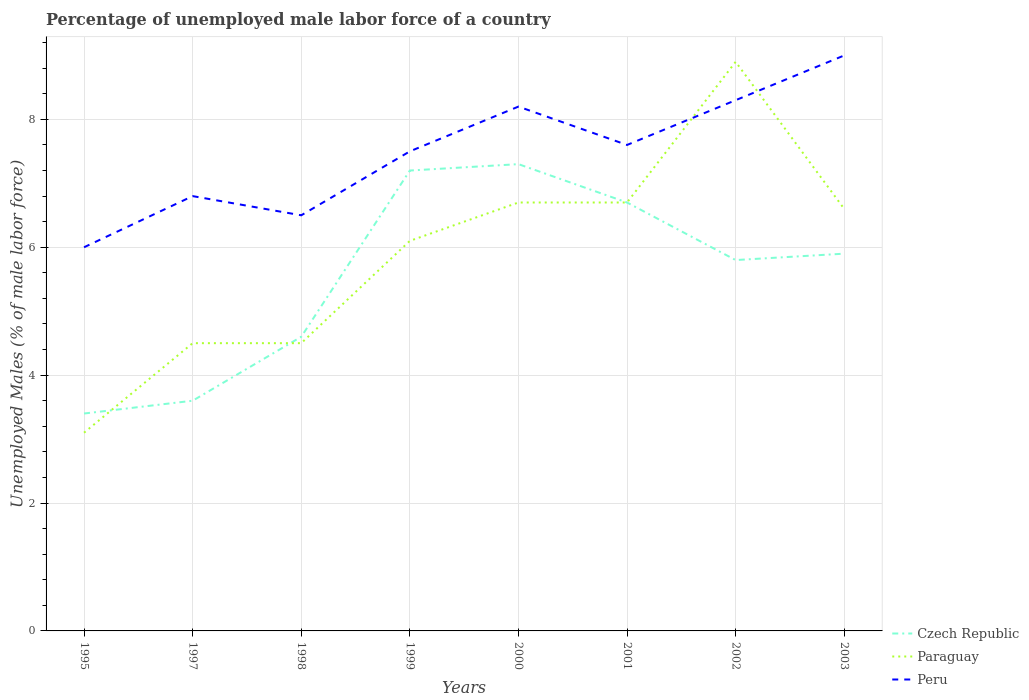How many different coloured lines are there?
Ensure brevity in your answer.  3. Does the line corresponding to Peru intersect with the line corresponding to Czech Republic?
Provide a short and direct response. No. Across all years, what is the maximum percentage of unemployed male labor force in Paraguay?
Your answer should be compact. 3.1. What is the total percentage of unemployed male labor force in Czech Republic in the graph?
Your answer should be very brief. -2.1. What is the difference between the highest and the second highest percentage of unemployed male labor force in Czech Republic?
Keep it short and to the point. 3.9. What is the difference between the highest and the lowest percentage of unemployed male labor force in Paraguay?
Your response must be concise. 5. Is the percentage of unemployed male labor force in Czech Republic strictly greater than the percentage of unemployed male labor force in Paraguay over the years?
Provide a short and direct response. No. How many lines are there?
Make the answer very short. 3. What is the difference between two consecutive major ticks on the Y-axis?
Provide a short and direct response. 2. Does the graph contain grids?
Your response must be concise. Yes. Where does the legend appear in the graph?
Your answer should be very brief. Bottom right. How many legend labels are there?
Your answer should be compact. 3. How are the legend labels stacked?
Provide a succinct answer. Vertical. What is the title of the graph?
Give a very brief answer. Percentage of unemployed male labor force of a country. What is the label or title of the Y-axis?
Your answer should be compact. Unemployed Males (% of male labor force). What is the Unemployed Males (% of male labor force) in Czech Republic in 1995?
Provide a short and direct response. 3.4. What is the Unemployed Males (% of male labor force) in Paraguay in 1995?
Offer a very short reply. 3.1. What is the Unemployed Males (% of male labor force) in Peru in 1995?
Provide a succinct answer. 6. What is the Unemployed Males (% of male labor force) of Czech Republic in 1997?
Ensure brevity in your answer.  3.6. What is the Unemployed Males (% of male labor force) in Paraguay in 1997?
Provide a short and direct response. 4.5. What is the Unemployed Males (% of male labor force) in Peru in 1997?
Offer a very short reply. 6.8. What is the Unemployed Males (% of male labor force) of Czech Republic in 1998?
Ensure brevity in your answer.  4.6. What is the Unemployed Males (% of male labor force) of Peru in 1998?
Provide a short and direct response. 6.5. What is the Unemployed Males (% of male labor force) in Czech Republic in 1999?
Offer a terse response. 7.2. What is the Unemployed Males (% of male labor force) of Paraguay in 1999?
Keep it short and to the point. 6.1. What is the Unemployed Males (% of male labor force) of Peru in 1999?
Make the answer very short. 7.5. What is the Unemployed Males (% of male labor force) in Czech Republic in 2000?
Offer a very short reply. 7.3. What is the Unemployed Males (% of male labor force) of Paraguay in 2000?
Keep it short and to the point. 6.7. What is the Unemployed Males (% of male labor force) of Peru in 2000?
Offer a terse response. 8.2. What is the Unemployed Males (% of male labor force) of Czech Republic in 2001?
Your answer should be compact. 6.7. What is the Unemployed Males (% of male labor force) of Paraguay in 2001?
Offer a very short reply. 6.7. What is the Unemployed Males (% of male labor force) in Peru in 2001?
Offer a very short reply. 7.6. What is the Unemployed Males (% of male labor force) in Czech Republic in 2002?
Your answer should be compact. 5.8. What is the Unemployed Males (% of male labor force) in Paraguay in 2002?
Provide a succinct answer. 8.9. What is the Unemployed Males (% of male labor force) of Peru in 2002?
Give a very brief answer. 8.3. What is the Unemployed Males (% of male labor force) of Czech Republic in 2003?
Make the answer very short. 5.9. What is the Unemployed Males (% of male labor force) in Paraguay in 2003?
Give a very brief answer. 6.6. What is the Unemployed Males (% of male labor force) in Peru in 2003?
Provide a succinct answer. 9. Across all years, what is the maximum Unemployed Males (% of male labor force) in Czech Republic?
Provide a succinct answer. 7.3. Across all years, what is the maximum Unemployed Males (% of male labor force) of Paraguay?
Your answer should be compact. 8.9. Across all years, what is the maximum Unemployed Males (% of male labor force) in Peru?
Provide a short and direct response. 9. Across all years, what is the minimum Unemployed Males (% of male labor force) of Czech Republic?
Offer a terse response. 3.4. Across all years, what is the minimum Unemployed Males (% of male labor force) of Paraguay?
Your answer should be compact. 3.1. Across all years, what is the minimum Unemployed Males (% of male labor force) of Peru?
Your answer should be compact. 6. What is the total Unemployed Males (% of male labor force) of Czech Republic in the graph?
Ensure brevity in your answer.  44.5. What is the total Unemployed Males (% of male labor force) in Paraguay in the graph?
Your answer should be very brief. 47.1. What is the total Unemployed Males (% of male labor force) in Peru in the graph?
Give a very brief answer. 59.9. What is the difference between the Unemployed Males (% of male labor force) in Czech Republic in 1995 and that in 1997?
Offer a terse response. -0.2. What is the difference between the Unemployed Males (% of male labor force) in Peru in 1995 and that in 1997?
Your answer should be very brief. -0.8. What is the difference between the Unemployed Males (% of male labor force) of Paraguay in 1995 and that in 1998?
Offer a very short reply. -1.4. What is the difference between the Unemployed Males (% of male labor force) of Paraguay in 1995 and that in 1999?
Provide a short and direct response. -3. What is the difference between the Unemployed Males (% of male labor force) of Peru in 1995 and that in 1999?
Offer a very short reply. -1.5. What is the difference between the Unemployed Males (% of male labor force) of Paraguay in 1995 and that in 2000?
Your answer should be very brief. -3.6. What is the difference between the Unemployed Males (% of male labor force) in Peru in 1995 and that in 2000?
Offer a very short reply. -2.2. What is the difference between the Unemployed Males (% of male labor force) of Czech Republic in 1995 and that in 2002?
Your answer should be compact. -2.4. What is the difference between the Unemployed Males (% of male labor force) in Paraguay in 1995 and that in 2002?
Your response must be concise. -5.8. What is the difference between the Unemployed Males (% of male labor force) in Paraguay in 1995 and that in 2003?
Provide a short and direct response. -3.5. What is the difference between the Unemployed Males (% of male labor force) of Czech Republic in 1997 and that in 1998?
Ensure brevity in your answer.  -1. What is the difference between the Unemployed Males (% of male labor force) of Paraguay in 1997 and that in 1998?
Your answer should be compact. 0. What is the difference between the Unemployed Males (% of male labor force) in Peru in 1997 and that in 1998?
Make the answer very short. 0.3. What is the difference between the Unemployed Males (% of male labor force) in Czech Republic in 1997 and that in 1999?
Provide a succinct answer. -3.6. What is the difference between the Unemployed Males (% of male labor force) in Paraguay in 1997 and that in 1999?
Ensure brevity in your answer.  -1.6. What is the difference between the Unemployed Males (% of male labor force) in Peru in 1997 and that in 1999?
Your response must be concise. -0.7. What is the difference between the Unemployed Males (% of male labor force) of Czech Republic in 1997 and that in 2000?
Offer a terse response. -3.7. What is the difference between the Unemployed Males (% of male labor force) of Peru in 1997 and that in 2001?
Offer a terse response. -0.8. What is the difference between the Unemployed Males (% of male labor force) of Peru in 1998 and that in 2000?
Offer a terse response. -1.7. What is the difference between the Unemployed Males (% of male labor force) of Paraguay in 1998 and that in 2001?
Provide a succinct answer. -2.2. What is the difference between the Unemployed Males (% of male labor force) of Czech Republic in 1998 and that in 2002?
Give a very brief answer. -1.2. What is the difference between the Unemployed Males (% of male labor force) in Paraguay in 1998 and that in 2002?
Make the answer very short. -4.4. What is the difference between the Unemployed Males (% of male labor force) of Czech Republic in 1998 and that in 2003?
Provide a succinct answer. -1.3. What is the difference between the Unemployed Males (% of male labor force) of Czech Republic in 1999 and that in 2000?
Your response must be concise. -0.1. What is the difference between the Unemployed Males (% of male labor force) of Peru in 1999 and that in 2000?
Offer a terse response. -0.7. What is the difference between the Unemployed Males (% of male labor force) in Paraguay in 1999 and that in 2001?
Make the answer very short. -0.6. What is the difference between the Unemployed Males (% of male labor force) of Peru in 1999 and that in 2001?
Provide a short and direct response. -0.1. What is the difference between the Unemployed Males (% of male labor force) in Czech Republic in 1999 and that in 2002?
Offer a very short reply. 1.4. What is the difference between the Unemployed Males (% of male labor force) in Czech Republic in 1999 and that in 2003?
Your answer should be compact. 1.3. What is the difference between the Unemployed Males (% of male labor force) in Peru in 1999 and that in 2003?
Provide a succinct answer. -1.5. What is the difference between the Unemployed Males (% of male labor force) of Paraguay in 2000 and that in 2001?
Keep it short and to the point. 0. What is the difference between the Unemployed Males (% of male labor force) of Czech Republic in 2000 and that in 2002?
Ensure brevity in your answer.  1.5. What is the difference between the Unemployed Males (% of male labor force) of Paraguay in 2000 and that in 2002?
Provide a short and direct response. -2.2. What is the difference between the Unemployed Males (% of male labor force) in Czech Republic in 2000 and that in 2003?
Offer a very short reply. 1.4. What is the difference between the Unemployed Males (% of male labor force) of Paraguay in 2000 and that in 2003?
Provide a succinct answer. 0.1. What is the difference between the Unemployed Males (% of male labor force) in Peru in 2000 and that in 2003?
Your response must be concise. -0.8. What is the difference between the Unemployed Males (% of male labor force) in Paraguay in 2001 and that in 2002?
Ensure brevity in your answer.  -2.2. What is the difference between the Unemployed Males (% of male labor force) of Peru in 2001 and that in 2002?
Your response must be concise. -0.7. What is the difference between the Unemployed Males (% of male labor force) of Peru in 2001 and that in 2003?
Your response must be concise. -1.4. What is the difference between the Unemployed Males (% of male labor force) of Czech Republic in 2002 and that in 2003?
Your response must be concise. -0.1. What is the difference between the Unemployed Males (% of male labor force) of Peru in 2002 and that in 2003?
Your response must be concise. -0.7. What is the difference between the Unemployed Males (% of male labor force) of Czech Republic in 1995 and the Unemployed Males (% of male labor force) of Paraguay in 1998?
Provide a short and direct response. -1.1. What is the difference between the Unemployed Males (% of male labor force) of Paraguay in 1995 and the Unemployed Males (% of male labor force) of Peru in 1998?
Offer a very short reply. -3.4. What is the difference between the Unemployed Males (% of male labor force) of Paraguay in 1995 and the Unemployed Males (% of male labor force) of Peru in 1999?
Your response must be concise. -4.4. What is the difference between the Unemployed Males (% of male labor force) of Czech Republic in 1995 and the Unemployed Males (% of male labor force) of Paraguay in 2000?
Keep it short and to the point. -3.3. What is the difference between the Unemployed Males (% of male labor force) of Czech Republic in 1995 and the Unemployed Males (% of male labor force) of Peru in 2000?
Your answer should be compact. -4.8. What is the difference between the Unemployed Males (% of male labor force) of Paraguay in 1995 and the Unemployed Males (% of male labor force) of Peru in 2000?
Provide a succinct answer. -5.1. What is the difference between the Unemployed Males (% of male labor force) of Czech Republic in 1995 and the Unemployed Males (% of male labor force) of Peru in 2001?
Offer a very short reply. -4.2. What is the difference between the Unemployed Males (% of male labor force) of Czech Republic in 1995 and the Unemployed Males (% of male labor force) of Paraguay in 2002?
Ensure brevity in your answer.  -5.5. What is the difference between the Unemployed Males (% of male labor force) in Paraguay in 1995 and the Unemployed Males (% of male labor force) in Peru in 2002?
Provide a succinct answer. -5.2. What is the difference between the Unemployed Males (% of male labor force) in Czech Republic in 1997 and the Unemployed Males (% of male labor force) in Paraguay in 1998?
Give a very brief answer. -0.9. What is the difference between the Unemployed Males (% of male labor force) of Czech Republic in 1997 and the Unemployed Males (% of male labor force) of Peru in 1998?
Make the answer very short. -2.9. What is the difference between the Unemployed Males (% of male labor force) in Paraguay in 1997 and the Unemployed Males (% of male labor force) in Peru in 1998?
Your response must be concise. -2. What is the difference between the Unemployed Males (% of male labor force) in Czech Republic in 1997 and the Unemployed Males (% of male labor force) in Peru in 1999?
Your answer should be very brief. -3.9. What is the difference between the Unemployed Males (% of male labor force) in Paraguay in 1997 and the Unemployed Males (% of male labor force) in Peru in 1999?
Provide a short and direct response. -3. What is the difference between the Unemployed Males (% of male labor force) of Czech Republic in 1997 and the Unemployed Males (% of male labor force) of Peru in 2000?
Provide a short and direct response. -4.6. What is the difference between the Unemployed Males (% of male labor force) in Paraguay in 1997 and the Unemployed Males (% of male labor force) in Peru in 2000?
Your answer should be compact. -3.7. What is the difference between the Unemployed Males (% of male labor force) of Czech Republic in 1997 and the Unemployed Males (% of male labor force) of Paraguay in 2001?
Ensure brevity in your answer.  -3.1. What is the difference between the Unemployed Males (% of male labor force) in Paraguay in 1997 and the Unemployed Males (% of male labor force) in Peru in 2001?
Make the answer very short. -3.1. What is the difference between the Unemployed Males (% of male labor force) of Paraguay in 1997 and the Unemployed Males (% of male labor force) of Peru in 2002?
Offer a terse response. -3.8. What is the difference between the Unemployed Males (% of male labor force) in Czech Republic in 1997 and the Unemployed Males (% of male labor force) in Paraguay in 2003?
Your answer should be very brief. -3. What is the difference between the Unemployed Males (% of male labor force) in Czech Republic in 1997 and the Unemployed Males (% of male labor force) in Peru in 2003?
Provide a short and direct response. -5.4. What is the difference between the Unemployed Males (% of male labor force) in Czech Republic in 1998 and the Unemployed Males (% of male labor force) in Paraguay in 1999?
Give a very brief answer. -1.5. What is the difference between the Unemployed Males (% of male labor force) of Czech Republic in 1998 and the Unemployed Males (% of male labor force) of Peru in 2000?
Your answer should be compact. -3.6. What is the difference between the Unemployed Males (% of male labor force) in Paraguay in 1998 and the Unemployed Males (% of male labor force) in Peru in 2000?
Your answer should be compact. -3.7. What is the difference between the Unemployed Males (% of male labor force) of Czech Republic in 1998 and the Unemployed Males (% of male labor force) of Paraguay in 2001?
Your answer should be compact. -2.1. What is the difference between the Unemployed Males (% of male labor force) of Czech Republic in 1998 and the Unemployed Males (% of male labor force) of Peru in 2001?
Your answer should be very brief. -3. What is the difference between the Unemployed Males (% of male labor force) of Paraguay in 1998 and the Unemployed Males (% of male labor force) of Peru in 2001?
Provide a short and direct response. -3.1. What is the difference between the Unemployed Males (% of male labor force) in Czech Republic in 1998 and the Unemployed Males (% of male labor force) in Peru in 2002?
Make the answer very short. -3.7. What is the difference between the Unemployed Males (% of male labor force) of Czech Republic in 1999 and the Unemployed Males (% of male labor force) of Paraguay in 2000?
Provide a short and direct response. 0.5. What is the difference between the Unemployed Males (% of male labor force) of Paraguay in 1999 and the Unemployed Males (% of male labor force) of Peru in 2000?
Provide a short and direct response. -2.1. What is the difference between the Unemployed Males (% of male labor force) of Czech Republic in 1999 and the Unemployed Males (% of male labor force) of Paraguay in 2001?
Offer a very short reply. 0.5. What is the difference between the Unemployed Males (% of male labor force) in Czech Republic in 1999 and the Unemployed Males (% of male labor force) in Peru in 2001?
Provide a succinct answer. -0.4. What is the difference between the Unemployed Males (% of male labor force) in Czech Republic in 1999 and the Unemployed Males (% of male labor force) in Paraguay in 2002?
Ensure brevity in your answer.  -1.7. What is the difference between the Unemployed Males (% of male labor force) of Czech Republic in 1999 and the Unemployed Males (% of male labor force) of Peru in 2002?
Your answer should be compact. -1.1. What is the difference between the Unemployed Males (% of male labor force) of Paraguay in 1999 and the Unemployed Males (% of male labor force) of Peru in 2002?
Provide a succinct answer. -2.2. What is the difference between the Unemployed Males (% of male labor force) in Czech Republic in 1999 and the Unemployed Males (% of male labor force) in Paraguay in 2003?
Make the answer very short. 0.6. What is the difference between the Unemployed Males (% of male labor force) in Czech Republic in 2000 and the Unemployed Males (% of male labor force) in Paraguay in 2002?
Keep it short and to the point. -1.6. What is the difference between the Unemployed Males (% of male labor force) of Czech Republic in 2000 and the Unemployed Males (% of male labor force) of Peru in 2002?
Your response must be concise. -1. What is the difference between the Unemployed Males (% of male labor force) of Czech Republic in 2000 and the Unemployed Males (% of male labor force) of Peru in 2003?
Provide a succinct answer. -1.7. What is the difference between the Unemployed Males (% of male labor force) of Paraguay in 2000 and the Unemployed Males (% of male labor force) of Peru in 2003?
Provide a short and direct response. -2.3. What is the difference between the Unemployed Males (% of male labor force) of Paraguay in 2001 and the Unemployed Males (% of male labor force) of Peru in 2003?
Your answer should be compact. -2.3. What is the difference between the Unemployed Males (% of male labor force) of Czech Republic in 2002 and the Unemployed Males (% of male labor force) of Peru in 2003?
Your answer should be very brief. -3.2. What is the difference between the Unemployed Males (% of male labor force) in Paraguay in 2002 and the Unemployed Males (% of male labor force) in Peru in 2003?
Make the answer very short. -0.1. What is the average Unemployed Males (% of male labor force) of Czech Republic per year?
Keep it short and to the point. 5.56. What is the average Unemployed Males (% of male labor force) in Paraguay per year?
Make the answer very short. 5.89. What is the average Unemployed Males (% of male labor force) in Peru per year?
Provide a short and direct response. 7.49. In the year 1995, what is the difference between the Unemployed Males (% of male labor force) in Czech Republic and Unemployed Males (% of male labor force) in Paraguay?
Provide a short and direct response. 0.3. In the year 1997, what is the difference between the Unemployed Males (% of male labor force) in Czech Republic and Unemployed Males (% of male labor force) in Paraguay?
Offer a very short reply. -0.9. In the year 1998, what is the difference between the Unemployed Males (% of male labor force) of Czech Republic and Unemployed Males (% of male labor force) of Peru?
Offer a terse response. -1.9. In the year 1999, what is the difference between the Unemployed Males (% of male labor force) in Czech Republic and Unemployed Males (% of male labor force) in Peru?
Provide a short and direct response. -0.3. In the year 2000, what is the difference between the Unemployed Males (% of male labor force) in Czech Republic and Unemployed Males (% of male labor force) in Paraguay?
Provide a short and direct response. 0.6. In the year 2001, what is the difference between the Unemployed Males (% of male labor force) in Czech Republic and Unemployed Males (% of male labor force) in Peru?
Ensure brevity in your answer.  -0.9. In the year 2001, what is the difference between the Unemployed Males (% of male labor force) in Paraguay and Unemployed Males (% of male labor force) in Peru?
Offer a very short reply. -0.9. In the year 2002, what is the difference between the Unemployed Males (% of male labor force) in Czech Republic and Unemployed Males (% of male labor force) in Paraguay?
Ensure brevity in your answer.  -3.1. In the year 2002, what is the difference between the Unemployed Males (% of male labor force) of Czech Republic and Unemployed Males (% of male labor force) of Peru?
Your answer should be very brief. -2.5. In the year 2003, what is the difference between the Unemployed Males (% of male labor force) of Czech Republic and Unemployed Males (% of male labor force) of Peru?
Ensure brevity in your answer.  -3.1. What is the ratio of the Unemployed Males (% of male labor force) in Czech Republic in 1995 to that in 1997?
Keep it short and to the point. 0.94. What is the ratio of the Unemployed Males (% of male labor force) in Paraguay in 1995 to that in 1997?
Ensure brevity in your answer.  0.69. What is the ratio of the Unemployed Males (% of male labor force) of Peru in 1995 to that in 1997?
Provide a succinct answer. 0.88. What is the ratio of the Unemployed Males (% of male labor force) in Czech Republic in 1995 to that in 1998?
Your response must be concise. 0.74. What is the ratio of the Unemployed Males (% of male labor force) of Paraguay in 1995 to that in 1998?
Provide a succinct answer. 0.69. What is the ratio of the Unemployed Males (% of male labor force) in Czech Republic in 1995 to that in 1999?
Your answer should be very brief. 0.47. What is the ratio of the Unemployed Males (% of male labor force) in Paraguay in 1995 to that in 1999?
Provide a short and direct response. 0.51. What is the ratio of the Unemployed Males (% of male labor force) in Peru in 1995 to that in 1999?
Offer a terse response. 0.8. What is the ratio of the Unemployed Males (% of male labor force) in Czech Republic in 1995 to that in 2000?
Ensure brevity in your answer.  0.47. What is the ratio of the Unemployed Males (% of male labor force) of Paraguay in 1995 to that in 2000?
Your answer should be compact. 0.46. What is the ratio of the Unemployed Males (% of male labor force) in Peru in 1995 to that in 2000?
Provide a succinct answer. 0.73. What is the ratio of the Unemployed Males (% of male labor force) of Czech Republic in 1995 to that in 2001?
Your answer should be compact. 0.51. What is the ratio of the Unemployed Males (% of male labor force) of Paraguay in 1995 to that in 2001?
Provide a short and direct response. 0.46. What is the ratio of the Unemployed Males (% of male labor force) of Peru in 1995 to that in 2001?
Provide a short and direct response. 0.79. What is the ratio of the Unemployed Males (% of male labor force) of Czech Republic in 1995 to that in 2002?
Give a very brief answer. 0.59. What is the ratio of the Unemployed Males (% of male labor force) in Paraguay in 1995 to that in 2002?
Your answer should be compact. 0.35. What is the ratio of the Unemployed Males (% of male labor force) of Peru in 1995 to that in 2002?
Your answer should be compact. 0.72. What is the ratio of the Unemployed Males (% of male labor force) in Czech Republic in 1995 to that in 2003?
Your answer should be compact. 0.58. What is the ratio of the Unemployed Males (% of male labor force) of Paraguay in 1995 to that in 2003?
Keep it short and to the point. 0.47. What is the ratio of the Unemployed Males (% of male labor force) in Czech Republic in 1997 to that in 1998?
Ensure brevity in your answer.  0.78. What is the ratio of the Unemployed Males (% of male labor force) in Peru in 1997 to that in 1998?
Provide a succinct answer. 1.05. What is the ratio of the Unemployed Males (% of male labor force) of Paraguay in 1997 to that in 1999?
Offer a terse response. 0.74. What is the ratio of the Unemployed Males (% of male labor force) of Peru in 1997 to that in 1999?
Your response must be concise. 0.91. What is the ratio of the Unemployed Males (% of male labor force) of Czech Republic in 1997 to that in 2000?
Provide a short and direct response. 0.49. What is the ratio of the Unemployed Males (% of male labor force) in Paraguay in 1997 to that in 2000?
Your response must be concise. 0.67. What is the ratio of the Unemployed Males (% of male labor force) in Peru in 1997 to that in 2000?
Offer a terse response. 0.83. What is the ratio of the Unemployed Males (% of male labor force) in Czech Republic in 1997 to that in 2001?
Provide a succinct answer. 0.54. What is the ratio of the Unemployed Males (% of male labor force) of Paraguay in 1997 to that in 2001?
Provide a short and direct response. 0.67. What is the ratio of the Unemployed Males (% of male labor force) of Peru in 1997 to that in 2001?
Provide a succinct answer. 0.89. What is the ratio of the Unemployed Males (% of male labor force) of Czech Republic in 1997 to that in 2002?
Make the answer very short. 0.62. What is the ratio of the Unemployed Males (% of male labor force) of Paraguay in 1997 to that in 2002?
Your answer should be compact. 0.51. What is the ratio of the Unemployed Males (% of male labor force) in Peru in 1997 to that in 2002?
Give a very brief answer. 0.82. What is the ratio of the Unemployed Males (% of male labor force) in Czech Republic in 1997 to that in 2003?
Offer a terse response. 0.61. What is the ratio of the Unemployed Males (% of male labor force) in Paraguay in 1997 to that in 2003?
Your response must be concise. 0.68. What is the ratio of the Unemployed Males (% of male labor force) in Peru in 1997 to that in 2003?
Offer a very short reply. 0.76. What is the ratio of the Unemployed Males (% of male labor force) in Czech Republic in 1998 to that in 1999?
Your answer should be very brief. 0.64. What is the ratio of the Unemployed Males (% of male labor force) of Paraguay in 1998 to that in 1999?
Offer a very short reply. 0.74. What is the ratio of the Unemployed Males (% of male labor force) in Peru in 1998 to that in 1999?
Your response must be concise. 0.87. What is the ratio of the Unemployed Males (% of male labor force) in Czech Republic in 1998 to that in 2000?
Your response must be concise. 0.63. What is the ratio of the Unemployed Males (% of male labor force) in Paraguay in 1998 to that in 2000?
Keep it short and to the point. 0.67. What is the ratio of the Unemployed Males (% of male labor force) of Peru in 1998 to that in 2000?
Keep it short and to the point. 0.79. What is the ratio of the Unemployed Males (% of male labor force) of Czech Republic in 1998 to that in 2001?
Provide a short and direct response. 0.69. What is the ratio of the Unemployed Males (% of male labor force) of Paraguay in 1998 to that in 2001?
Offer a very short reply. 0.67. What is the ratio of the Unemployed Males (% of male labor force) in Peru in 1998 to that in 2001?
Your answer should be very brief. 0.86. What is the ratio of the Unemployed Males (% of male labor force) in Czech Republic in 1998 to that in 2002?
Your answer should be compact. 0.79. What is the ratio of the Unemployed Males (% of male labor force) of Paraguay in 1998 to that in 2002?
Your response must be concise. 0.51. What is the ratio of the Unemployed Males (% of male labor force) of Peru in 1998 to that in 2002?
Your response must be concise. 0.78. What is the ratio of the Unemployed Males (% of male labor force) in Czech Republic in 1998 to that in 2003?
Offer a terse response. 0.78. What is the ratio of the Unemployed Males (% of male labor force) of Paraguay in 1998 to that in 2003?
Offer a terse response. 0.68. What is the ratio of the Unemployed Males (% of male labor force) in Peru in 1998 to that in 2003?
Your answer should be very brief. 0.72. What is the ratio of the Unemployed Males (% of male labor force) in Czech Republic in 1999 to that in 2000?
Offer a very short reply. 0.99. What is the ratio of the Unemployed Males (% of male labor force) of Paraguay in 1999 to that in 2000?
Your answer should be very brief. 0.91. What is the ratio of the Unemployed Males (% of male labor force) of Peru in 1999 to that in 2000?
Ensure brevity in your answer.  0.91. What is the ratio of the Unemployed Males (% of male labor force) in Czech Republic in 1999 to that in 2001?
Offer a terse response. 1.07. What is the ratio of the Unemployed Males (% of male labor force) of Paraguay in 1999 to that in 2001?
Offer a very short reply. 0.91. What is the ratio of the Unemployed Males (% of male labor force) in Peru in 1999 to that in 2001?
Offer a very short reply. 0.99. What is the ratio of the Unemployed Males (% of male labor force) of Czech Republic in 1999 to that in 2002?
Provide a succinct answer. 1.24. What is the ratio of the Unemployed Males (% of male labor force) of Paraguay in 1999 to that in 2002?
Provide a succinct answer. 0.69. What is the ratio of the Unemployed Males (% of male labor force) of Peru in 1999 to that in 2002?
Make the answer very short. 0.9. What is the ratio of the Unemployed Males (% of male labor force) in Czech Republic in 1999 to that in 2003?
Your answer should be very brief. 1.22. What is the ratio of the Unemployed Males (% of male labor force) in Paraguay in 1999 to that in 2003?
Give a very brief answer. 0.92. What is the ratio of the Unemployed Males (% of male labor force) in Peru in 1999 to that in 2003?
Your response must be concise. 0.83. What is the ratio of the Unemployed Males (% of male labor force) of Czech Republic in 2000 to that in 2001?
Make the answer very short. 1.09. What is the ratio of the Unemployed Males (% of male labor force) in Paraguay in 2000 to that in 2001?
Keep it short and to the point. 1. What is the ratio of the Unemployed Males (% of male labor force) in Peru in 2000 to that in 2001?
Your answer should be very brief. 1.08. What is the ratio of the Unemployed Males (% of male labor force) of Czech Republic in 2000 to that in 2002?
Make the answer very short. 1.26. What is the ratio of the Unemployed Males (% of male labor force) of Paraguay in 2000 to that in 2002?
Make the answer very short. 0.75. What is the ratio of the Unemployed Males (% of male labor force) in Peru in 2000 to that in 2002?
Your response must be concise. 0.99. What is the ratio of the Unemployed Males (% of male labor force) in Czech Republic in 2000 to that in 2003?
Your answer should be very brief. 1.24. What is the ratio of the Unemployed Males (% of male labor force) in Paraguay in 2000 to that in 2003?
Your response must be concise. 1.02. What is the ratio of the Unemployed Males (% of male labor force) of Peru in 2000 to that in 2003?
Your answer should be very brief. 0.91. What is the ratio of the Unemployed Males (% of male labor force) in Czech Republic in 2001 to that in 2002?
Your answer should be compact. 1.16. What is the ratio of the Unemployed Males (% of male labor force) in Paraguay in 2001 to that in 2002?
Keep it short and to the point. 0.75. What is the ratio of the Unemployed Males (% of male labor force) in Peru in 2001 to that in 2002?
Make the answer very short. 0.92. What is the ratio of the Unemployed Males (% of male labor force) in Czech Republic in 2001 to that in 2003?
Your response must be concise. 1.14. What is the ratio of the Unemployed Males (% of male labor force) of Paraguay in 2001 to that in 2003?
Provide a short and direct response. 1.02. What is the ratio of the Unemployed Males (% of male labor force) of Peru in 2001 to that in 2003?
Give a very brief answer. 0.84. What is the ratio of the Unemployed Males (% of male labor force) of Czech Republic in 2002 to that in 2003?
Make the answer very short. 0.98. What is the ratio of the Unemployed Males (% of male labor force) in Paraguay in 2002 to that in 2003?
Give a very brief answer. 1.35. What is the ratio of the Unemployed Males (% of male labor force) of Peru in 2002 to that in 2003?
Keep it short and to the point. 0.92. What is the difference between the highest and the second highest Unemployed Males (% of male labor force) in Czech Republic?
Give a very brief answer. 0.1. What is the difference between the highest and the second highest Unemployed Males (% of male labor force) of Peru?
Provide a succinct answer. 0.7. What is the difference between the highest and the lowest Unemployed Males (% of male labor force) in Paraguay?
Give a very brief answer. 5.8. What is the difference between the highest and the lowest Unemployed Males (% of male labor force) in Peru?
Make the answer very short. 3. 